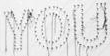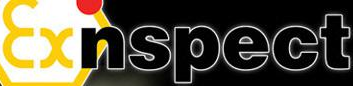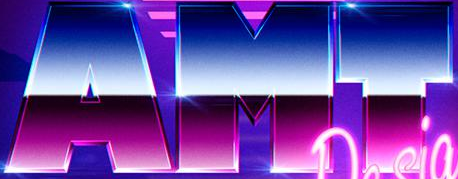What words are shown in these images in order, separated by a semicolon? YOU; Exnspect; AMT 